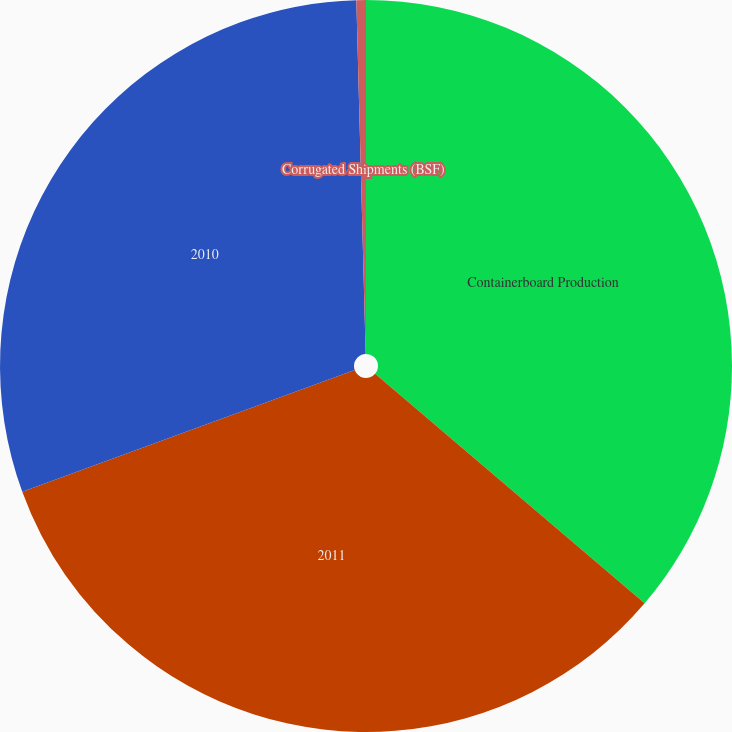Convert chart to OTSL. <chart><loc_0><loc_0><loc_500><loc_500><pie_chart><fcel>Containerboard Production<fcel>2011<fcel>2010<fcel>Corrugated Shipments (BSF)<nl><fcel>36.23%<fcel>33.19%<fcel>30.16%<fcel>0.42%<nl></chart> 